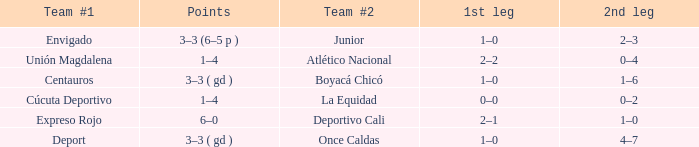What is the team #2 with Deport as team #1? Once Caldas. Would you mind parsing the complete table? {'header': ['Team #1', 'Points', 'Team #2', '1st leg', '2nd leg'], 'rows': [['Envigado', '3–3 (6–5 p )', 'Junior', '1–0', '2–3'], ['Unión Magdalena', '1–4', 'Atlético Nacional', '2–2', '0–4'], ['Centauros', '3–3 ( gd )', 'Boyacá Chicó', '1–0', '1–6'], ['Cúcuta Deportivo', '1–4', 'La Equidad', '0–0', '0–2'], ['Expreso Rojo', '6–0', 'Deportivo Cali', '2–1', '1–0'], ['Deport', '3–3 ( gd )', 'Once Caldas', '1–0', '4–7']]} 